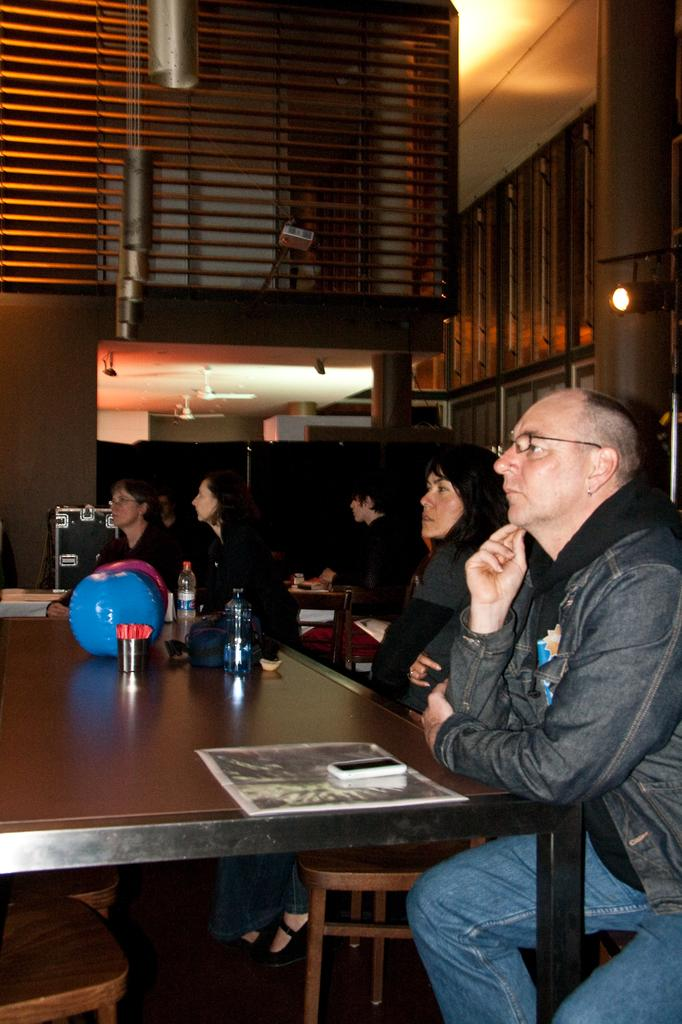What are the people in the image doing? The people in the image are sitting on chairs. What is present in the image besides the people? There is a table in the image. What objects can be seen on the table? There is a phone and bottles on the table. What type of yam is being served on the table in the image? There is no yam present in the image; the table only contains a phone and bottles. 